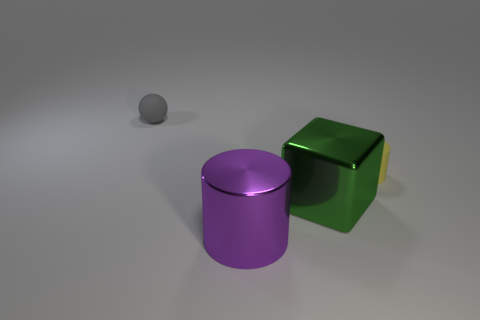Add 1 metal cubes. How many objects exist? 5 Subtract all blocks. How many objects are left? 3 Add 1 green objects. How many green objects exist? 2 Subtract 1 green blocks. How many objects are left? 3 Subtract all brown rubber things. Subtract all big things. How many objects are left? 2 Add 1 small gray rubber spheres. How many small gray rubber spheres are left? 2 